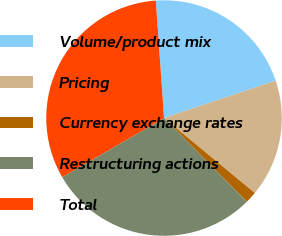Convert chart. <chart><loc_0><loc_0><loc_500><loc_500><pie_chart><fcel>Volume/product mix<fcel>Pricing<fcel>Currency exchange rates<fcel>Restructuring actions<fcel>Total<nl><fcel>20.97%<fcel>16.13%<fcel>1.61%<fcel>29.03%<fcel>32.26%<nl></chart> 